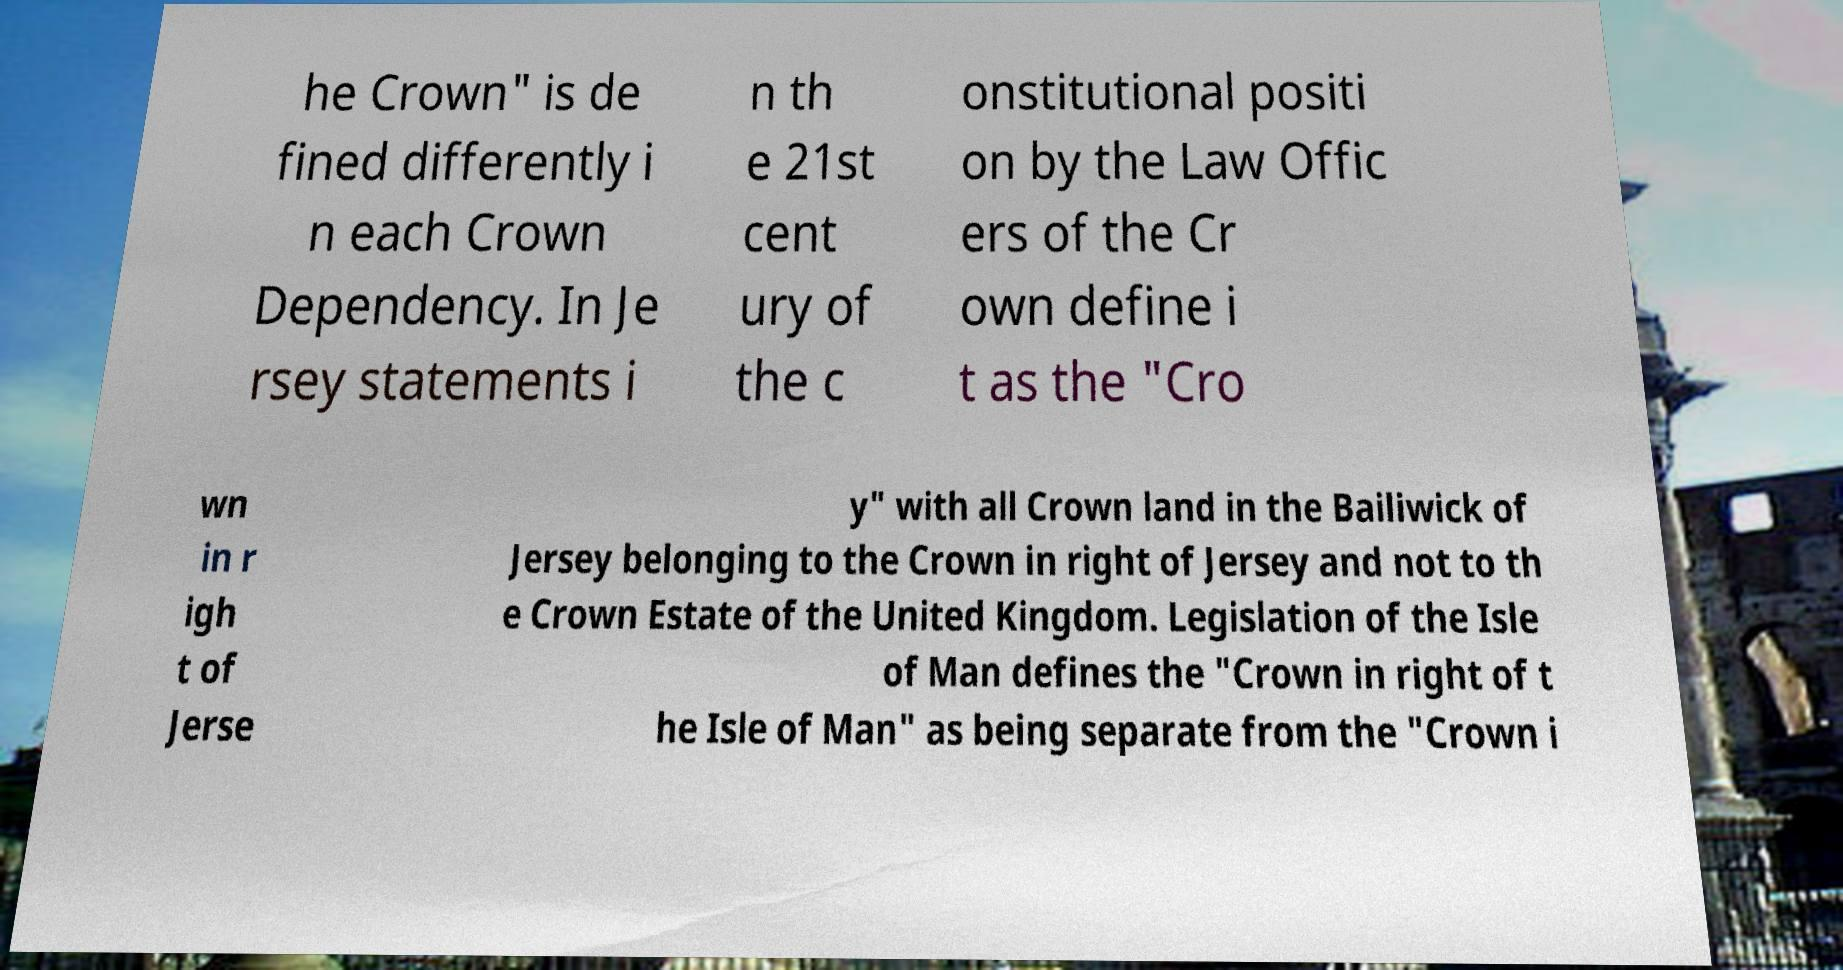Can you accurately transcribe the text from the provided image for me? he Crown" is de fined differently i n each Crown Dependency. In Je rsey statements i n th e 21st cent ury of the c onstitutional positi on by the Law Offic ers of the Cr own define i t as the "Cro wn in r igh t of Jerse y" with all Crown land in the Bailiwick of Jersey belonging to the Crown in right of Jersey and not to th e Crown Estate of the United Kingdom. Legislation of the Isle of Man defines the "Crown in right of t he Isle of Man" as being separate from the "Crown i 